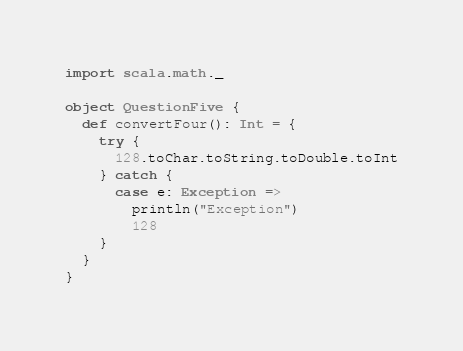<code> <loc_0><loc_0><loc_500><loc_500><_Scala_>
import scala.math._

object QuestionFive {
  def convertFour(): Int = {
    try {
      128.toChar.toString.toDouble.toInt
    } catch {
      case e: Exception =>
        println("Exception")
        128
    }
  }
}
</code> 